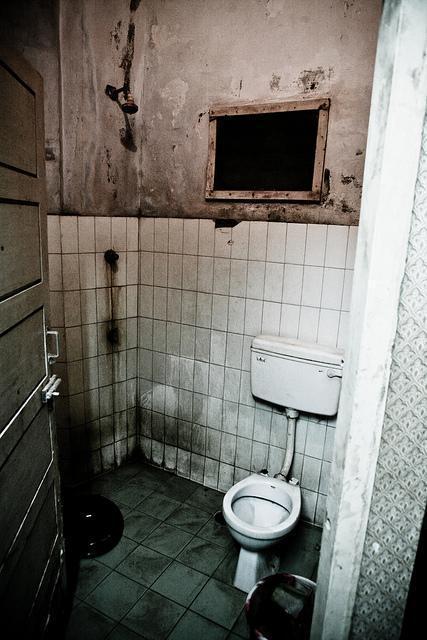How many people are holding skateboards?
Give a very brief answer. 0. 